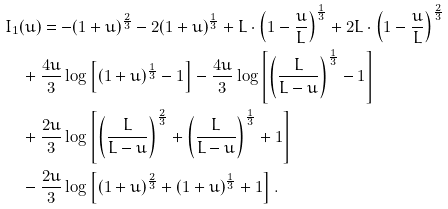Convert formula to latex. <formula><loc_0><loc_0><loc_500><loc_500>& I _ { 1 } ( u ) = - ( 1 + u ) ^ { \frac { 2 } { 3 } } - 2 ( 1 + u ) ^ { \frac { 1 } { 3 } } + L \cdot \left ( 1 - \frac { u } { L } \right ) ^ { \frac { 1 } { 3 } } + 2 L \cdot \left ( 1 - \frac { u } { L } \right ) ^ { \frac { 2 } { 3 } } \\ & \quad + \frac { 4 u } { 3 } \log \left [ ( 1 + u ) ^ { \frac { 1 } { 3 } } - 1 \right ] - \frac { 4 u } { 3 } \log \left [ \left ( \frac { L } { L - u } \right ) ^ { \frac { 1 } { 3 } } - 1 \right ] \\ & \quad + \frac { 2 u } { 3 } \log \left [ \left ( \frac { L } { L - u } \right ) ^ { \frac { 2 } { 3 } } + \left ( \frac { L } { L - u } \right ) ^ { \frac { 1 } { 3 } } + 1 \right ] \\ & \quad - \frac { 2 u } { 3 } \log \left [ ( 1 + u ) ^ { \frac { 2 } { 3 } } + ( 1 + u ) ^ { \frac { 1 } { 3 } } + 1 \right ] .</formula> 